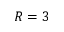<formula> <loc_0><loc_0><loc_500><loc_500>R = 3</formula> 